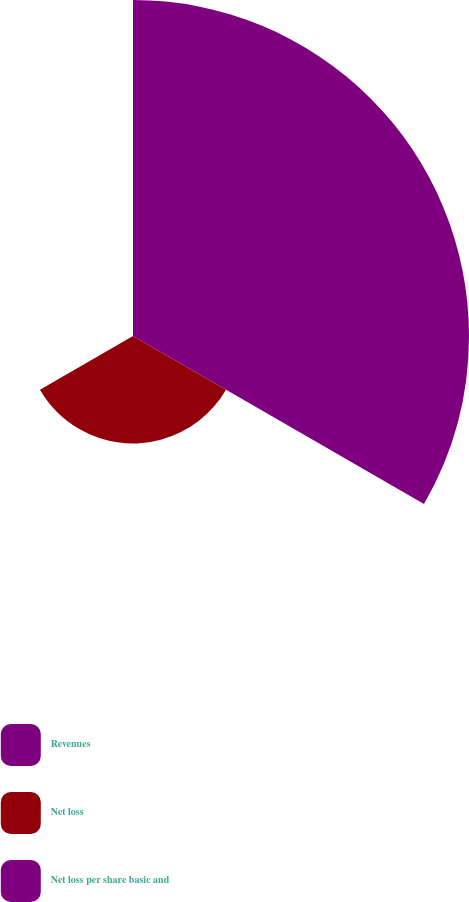Convert chart to OTSL. <chart><loc_0><loc_0><loc_500><loc_500><pie_chart><fcel>Revenues<fcel>Net loss<fcel>Net loss per share basic and<nl><fcel>75.78%<fcel>24.22%<fcel>0.0%<nl></chart> 